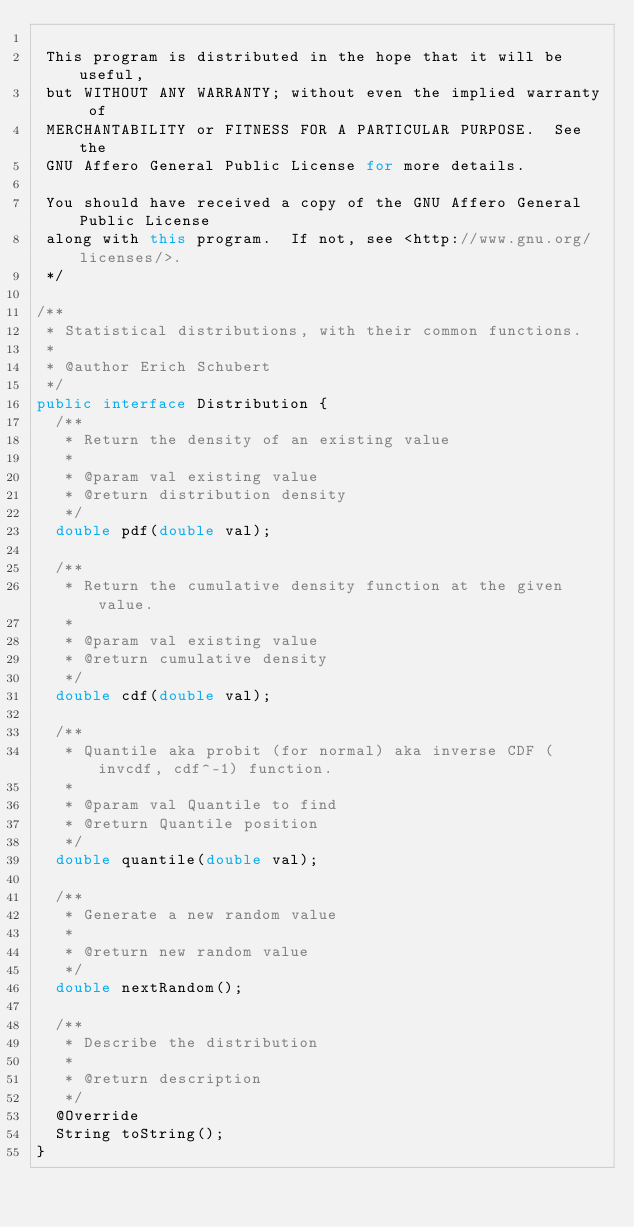<code> <loc_0><loc_0><loc_500><loc_500><_Java_>
 This program is distributed in the hope that it will be useful,
 but WITHOUT ANY WARRANTY; without even the implied warranty of
 MERCHANTABILITY or FITNESS FOR A PARTICULAR PURPOSE.  See the
 GNU Affero General Public License for more details.

 You should have received a copy of the GNU Affero General Public License
 along with this program.  If not, see <http://www.gnu.org/licenses/>.
 */

/**
 * Statistical distributions, with their common functions.
 * 
 * @author Erich Schubert
 */
public interface Distribution {
  /**
   * Return the density of an existing value
   * 
   * @param val existing value
   * @return distribution density
   */
  double pdf(double val);

  /**
   * Return the cumulative density function at the given value.
   * 
   * @param val existing value
   * @return cumulative density
   */
  double cdf(double val);

  /**
   * Quantile aka probit (for normal) aka inverse CDF (invcdf, cdf^-1) function.
   * 
   * @param val Quantile to find
   * @return Quantile position
   */
  double quantile(double val);

  /**
   * Generate a new random value
   * 
   * @return new random value
   */
  double nextRandom();

  /**
   * Describe the distribution
   * 
   * @return description
   */
  @Override
  String toString();
}
</code> 